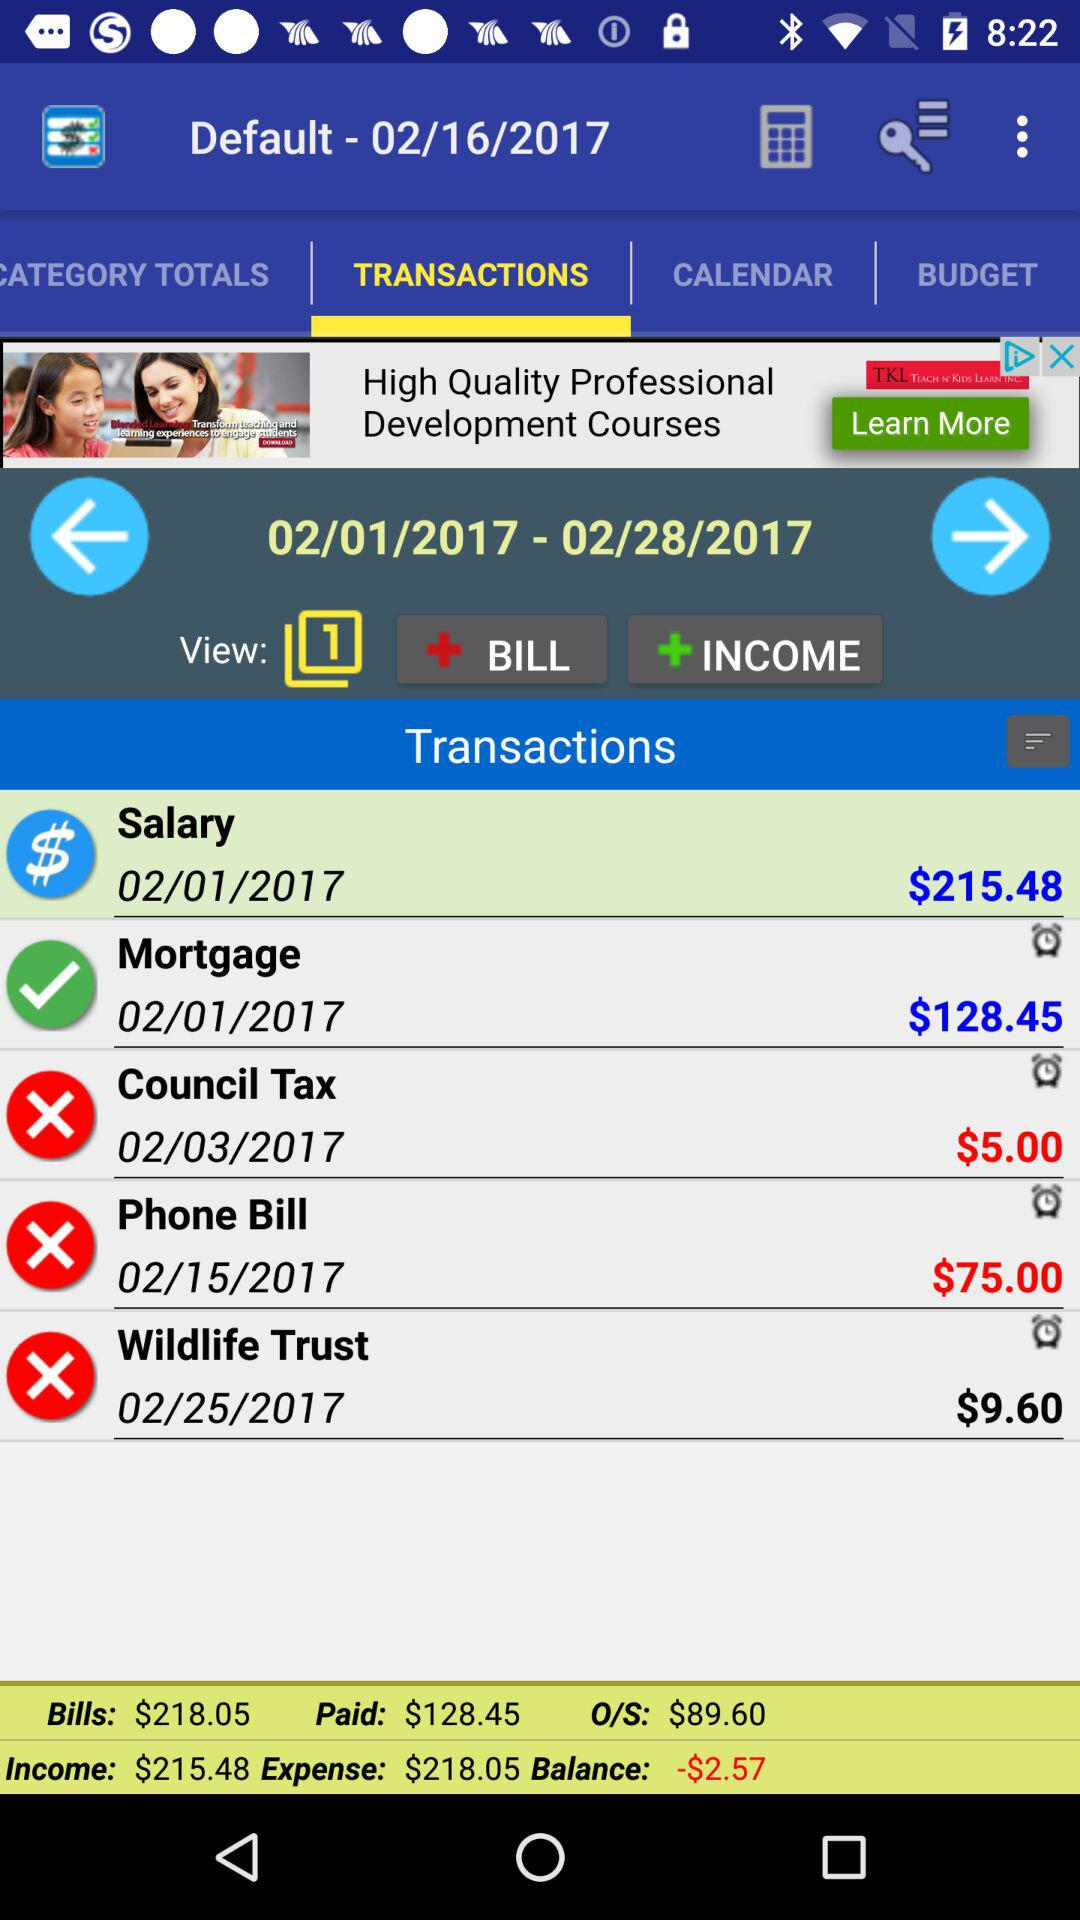How many views are there? There is 1 view. 